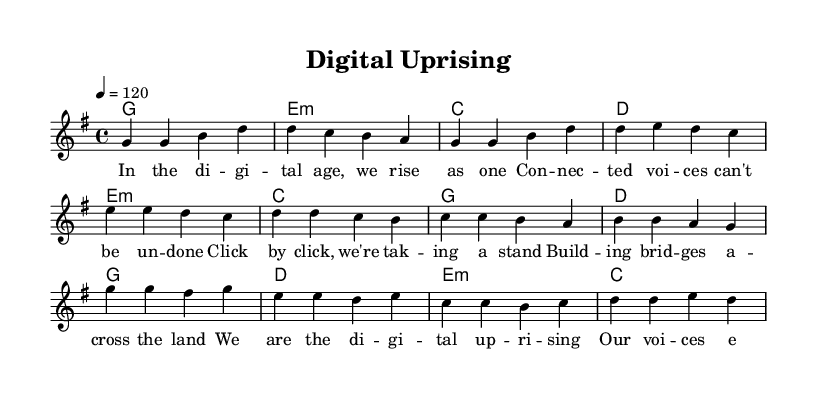What is the key signature of this music? The key signature is indicated at the beginning of the score. Here, it shows one sharp, which means the key is G major.
Answer: G major What is the time signature of this music? The time signature appears as a fraction at the beginning of the score. Here, it shows 4/4, meaning there are four beats per measure.
Answer: 4/4 What is the tempo marking of this piece? The tempo marking, indicated in beats per minute, states "4 = 120." This means there are 120 beats in one minute, establishing the speed of the piece.
Answer: 120 How many sections are in the song structure presented in the sheet? By analyzing the score, we can see there are three distinct sections labeled as Verse, Pre-Chorus, and Chorus in the melody part. This indicates three main sections.
Answer: 3 Which part contains the chorus? The score identifies the chorus, where the melody has a distinct pattern and starts with "g' g fis g." This labeling helps ascertain the section's location.
Answer: Chorus What is the emotional theme conveyed in the lyrics? The lyrics reflect a sense of unity and activism in the digital age. The words emphasize collective action and connection, which align with themes in contemporary pop anthems.
Answer: Unity and activism What chord is played during the verse? During the verse section, the first chord indicated is G major, as shown in the harmony part. Analyzing the first measure confirms this chord.
Answer: G major 